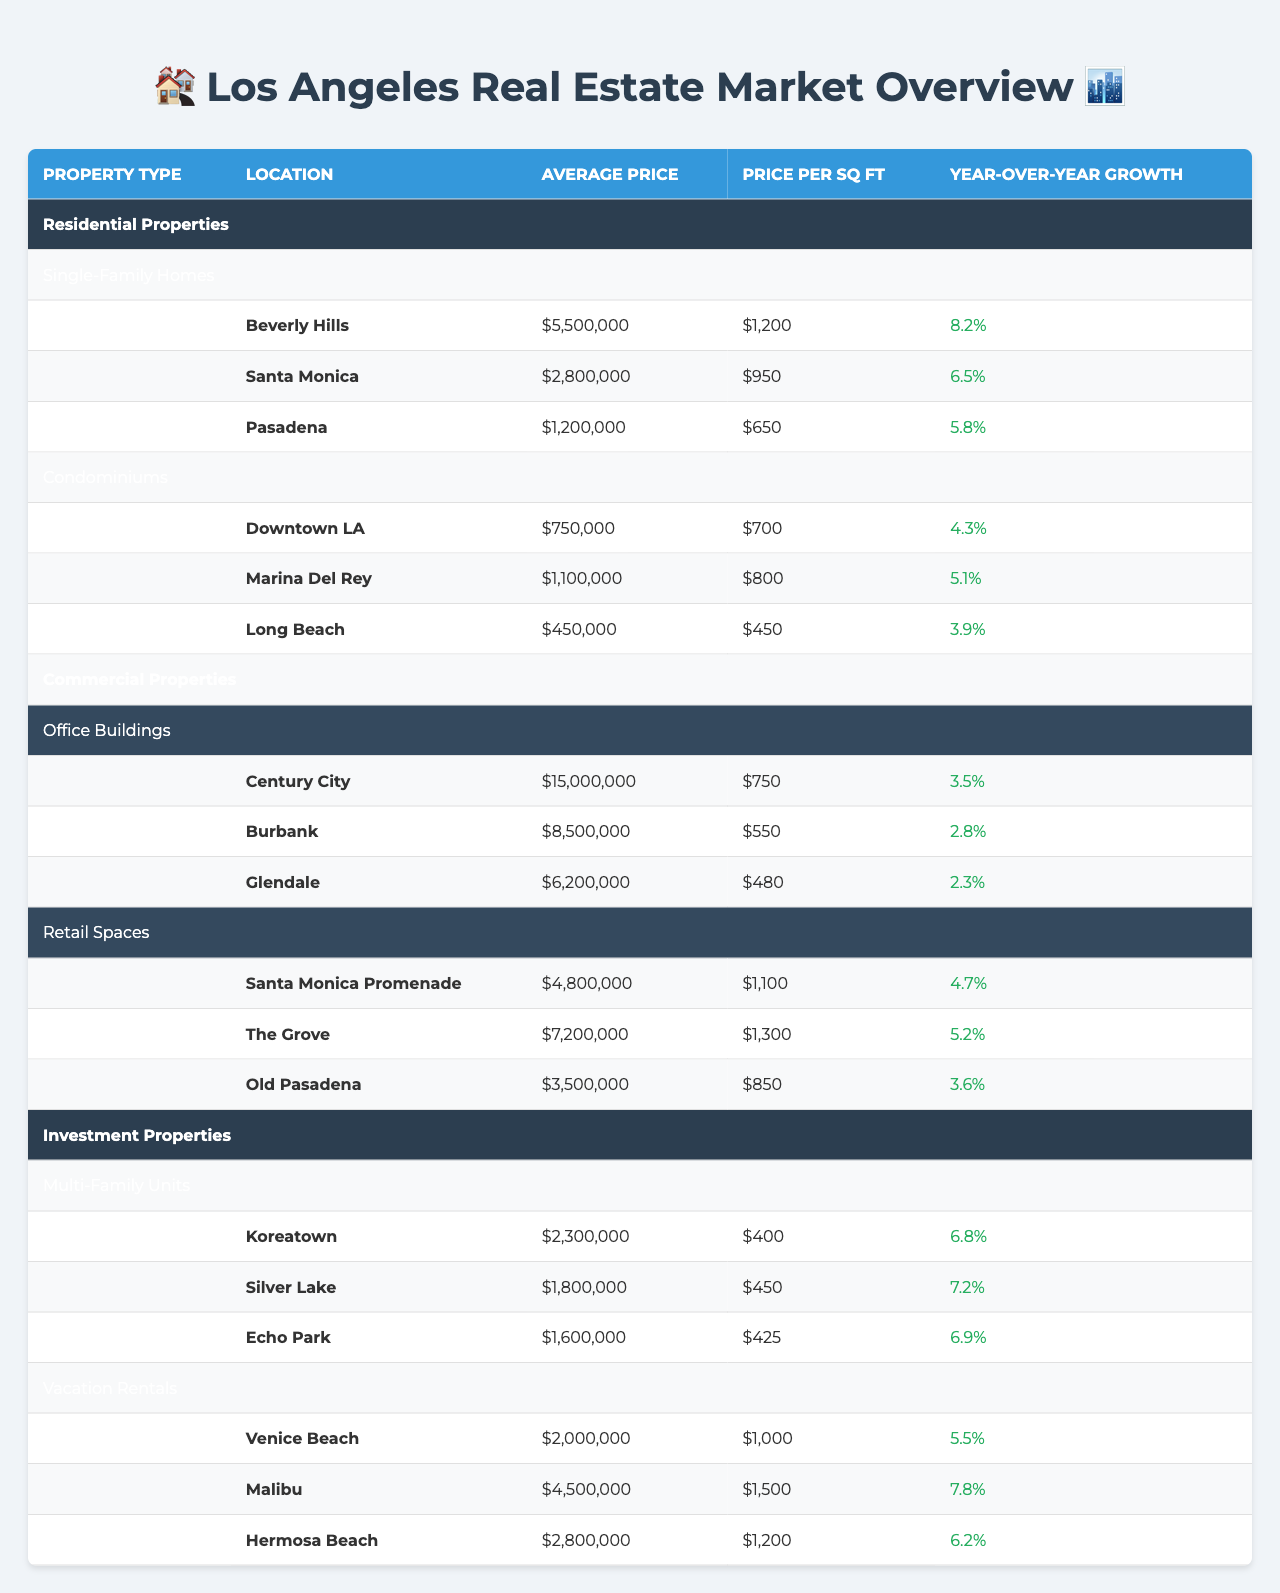What is the average price of Single-Family Homes in Pasadena? According to the table, the average price for Single-Family Homes in Pasadena is provided directly in the row corresponding to that location, which is $1,200,000.
Answer: $1,200,000 Which property type has the highest average price? By looking at the average prices listed for each property type, we find that "Office Buildings" has the highest average price at $15,000,000.
Answer: Office Buildings Is the Year-over-Year Growth for Long Beach Condominiums positive? Checking the Year-over-Year Growth for Long Beach Condominiums, it reads "3.9%", which is a positive value, thus confirming that the growth is indeed positive.
Answer: Yes What is the difference in average price between Beverly Hills and Santa Monica Single-Family Homes? The average price for Beverly Hills is $5,500,000, while for Santa Monica, it is $2,800,000. The difference is calculated as $5,500,000 - $2,800,000 = $2,700,000.
Answer: $2,700,000 Which neighborhood has the highest Price per Sq Ft among the Retail Spaces? In the Retail Spaces category, the highest Price per Sq Ft is found in The Grove, with a value of $1,300 per Sq Ft.
Answer: The Grove What is the average Year-over-Year Growth for Investment Properties? The Year-over-Year Growth values for Multi-Family Units are 6.8%, 7.2%, and 6.9% respectively, and for Vacation Rentals, they are 5.5%, 7.8%, and 6.2%. Summing them: (6.8 + 7.2 + 6.9 + 5.5 + 7.8 + 6.2) = 40.4 and dividing by 6 gives an average of approximately 6.73%.
Answer: 6.73% Do Condominiums in Downtown LA have a Year-over-Year Growth higher than 5%? The Year-over-Year Growth for Downtown LA Condominiums is 4.3%, which is not higher than 5%. Therefore, the answer is no.
Answer: No Which area has the lowest average price for its property type? By reviewing the average prices across all property types, Long Beach has the lowest average price at $450,000, which is for Condominiums.
Answer: Long Beach What is the Price per Sq Ft for Single-Family Homes in Santa Monica compared to Pasadena? Santa Monica has a Price per Sq Ft of $950, while Pasadena has $650. The difference is $950 - $650 = $300.
Answer: $300 Which property type shows the highest Year-over-Year Growth and what is the value? Comparing all Year-over-Year Growth values, the highest is for Malibu Vacation Rentals at 7.8%.
Answer: 7.8% In what location is the average price for Multi-Family Units higher, Koreatown or Silver Lake? Koreatown has an average price of $2,300,000, whereas Silver Lake has $1,800,000. Since $2,300,000 > $1,800,000, Koreatown has the higher average price.
Answer: Koreatown 